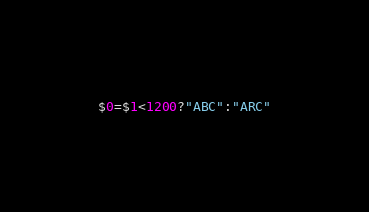<code> <loc_0><loc_0><loc_500><loc_500><_Awk_>$0=$1<1200?"ABC":"ARC"</code> 